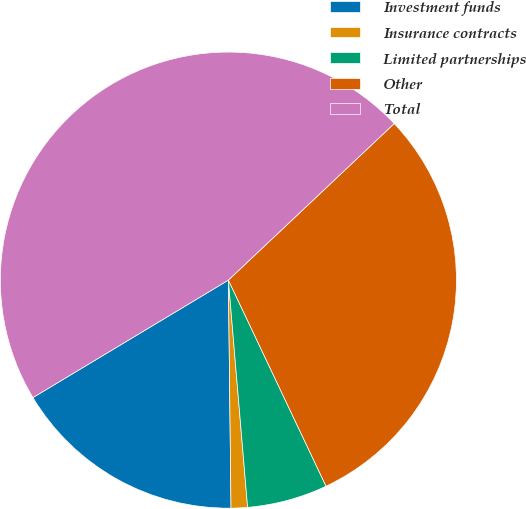Convert chart to OTSL. <chart><loc_0><loc_0><loc_500><loc_500><pie_chart><fcel>Investment funds<fcel>Insurance contracts<fcel>Limited partnerships<fcel>Other<fcel>Total<nl><fcel>16.57%<fcel>1.16%<fcel>5.7%<fcel>30.0%<fcel>46.57%<nl></chart> 